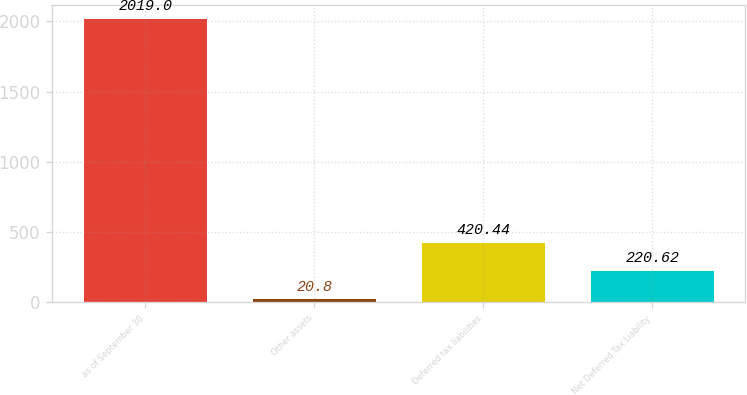Convert chart. <chart><loc_0><loc_0><loc_500><loc_500><bar_chart><fcel>as of September 30<fcel>Other assets<fcel>Deferred tax liabilities<fcel>Net Deferred Tax Liability<nl><fcel>2019<fcel>20.8<fcel>420.44<fcel>220.62<nl></chart> 